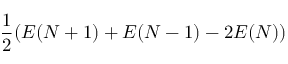Convert formula to latex. <formula><loc_0><loc_0><loc_500><loc_500>\frac { 1 } { 2 } ( E ( N + 1 ) + E ( N - 1 ) - 2 E ( N ) )</formula> 